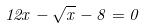Convert formula to latex. <formula><loc_0><loc_0><loc_500><loc_500>1 2 x - \sqrt { x } - 8 = 0</formula> 